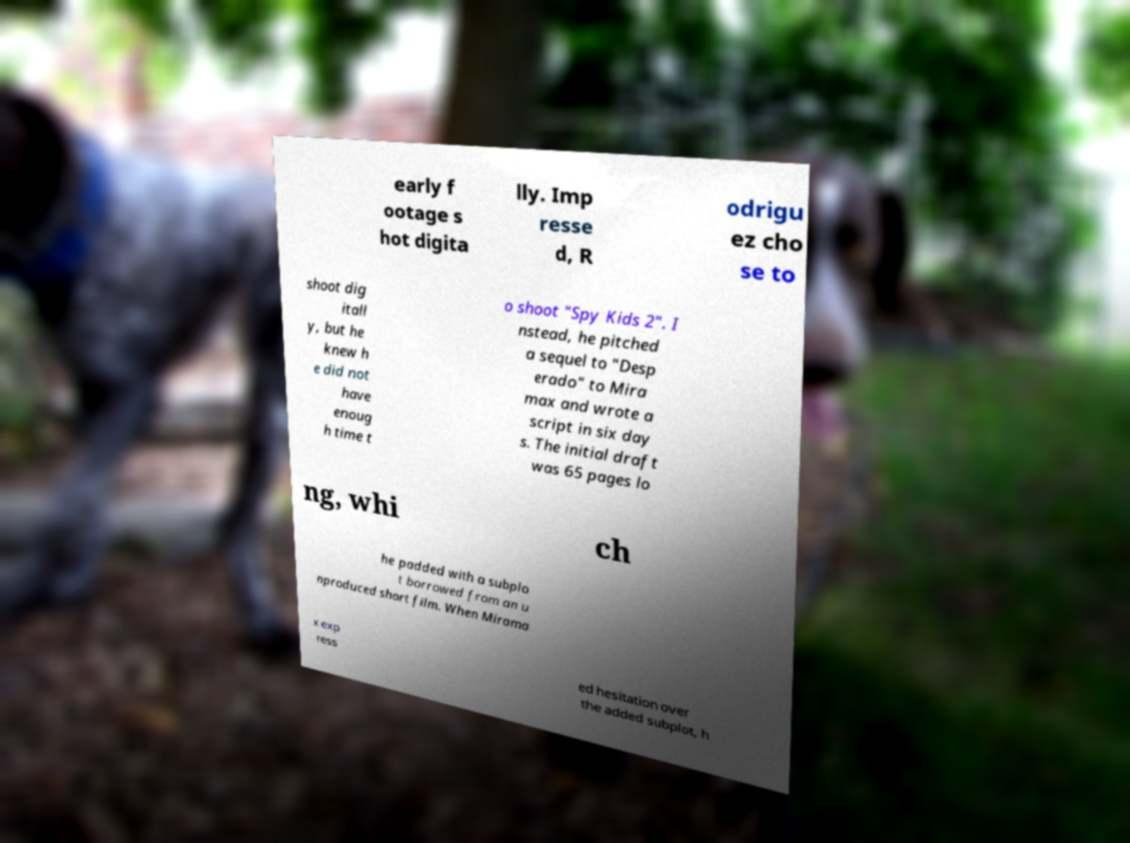Can you read and provide the text displayed in the image?This photo seems to have some interesting text. Can you extract and type it out for me? early f ootage s hot digita lly. Imp resse d, R odrigu ez cho se to shoot dig itall y, but he knew h e did not have enoug h time t o shoot "Spy Kids 2". I nstead, he pitched a sequel to "Desp erado" to Mira max and wrote a script in six day s. The initial draft was 65 pages lo ng, whi ch he padded with a subplo t borrowed from an u nproduced short film. When Mirama x exp ress ed hesitation over the added subplot, h 